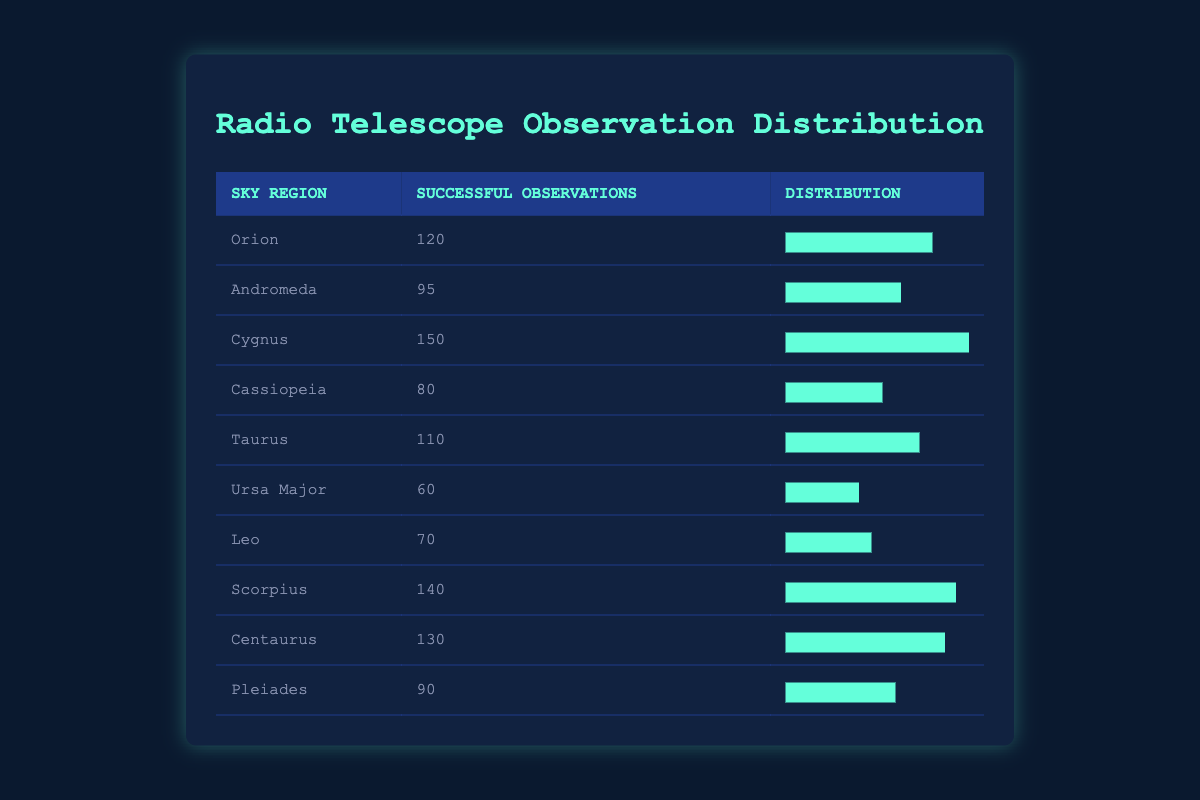What is the highest number of successful observations recorded? By looking at the "Successful Observations" column, we can identify the maximum value. The values are: 120 for Orion, 95 for Andromeda, 150 for Cygnus, 80 for Cassiopeia, 110 for Taurus, 60 for Ursa Major, 70 for Leo, 140 for Scorpius, 130 for Centaurus, and 90 for Pleiades. The highest value among them is 150 for Cygnus.
Answer: 150 Which sky region has the lowest number of successful observations? In the "Successful Observations" column, we analyze the counts for each region. We notice the minimum value is 60, which corresponds to Ursa Major.
Answer: Ursa Major Calculate the average number of successful observations across all regions. First, we sum the successful observations: 120 + 95 + 150 + 80 + 110 + 60 + 70 + 140 + 130 + 90 = 1,115. Next, we count the number of regions, which is 10. We then compute the average by dividing the total sum (1,115) by the number of regions (10), resulting in 111.5.
Answer: 111.5 Is the number of successful observations in Leo greater than the number in Taurus? Looking at the observations, Leo has 70 while Taurus has 110. Since 70 is less than 110, the statement is false.
Answer: No What is the total number of successful observations for the regions that represent more than 100 observations? We identify the regions with more than 100 successful observations: Cygnus (150), Scorpius (140), Centaurus (130), and Orion (120). We sum these values: 150 + 140 + 130 + 120 = 540.
Answer: 540 How many regions have successful observations less than 100? We check the observations for each region. The regions with counts less than 100 are: Andromeda (95), Cassiopeia (80), Ursa Major (60), Leo (70), and Pleiades (90). This gives us 5 regions.
Answer: 5 Which sky region has successful observations closest to the average? The average number of successful observations is 111.5. We compare this value with each region's count. The closest values are Taurus with 110 and Orion with 120. Taurus is just 1.5 away (110 - 111.5) and Orion is 8.5 away (120 - 111.5). Therefore, Taurus is closer.
Answer: Taurus 